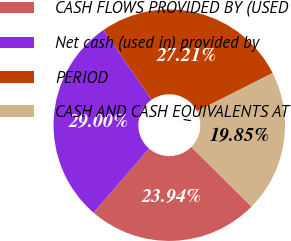Convert chart to OTSL. <chart><loc_0><loc_0><loc_500><loc_500><pie_chart><fcel>CASH FLOWS PROVIDED BY (USED<fcel>Net cash (used in) provided by<fcel>PERIOD<fcel>CASH AND CASH EQUIVALENTS AT<nl><fcel>23.94%<fcel>29.0%<fcel>27.21%<fcel>19.85%<nl></chart> 